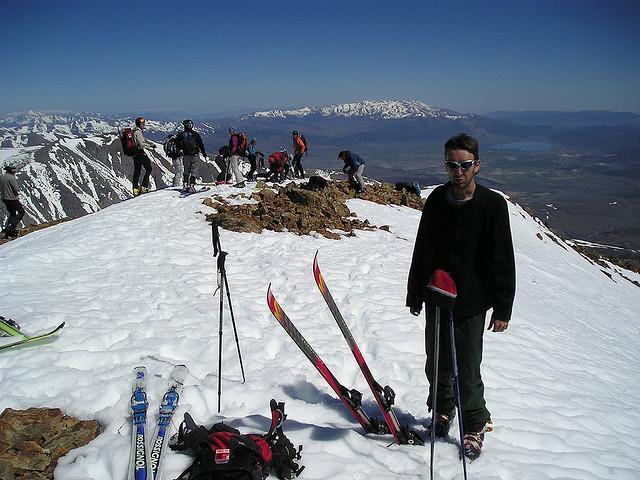How will everyone get off the top of the mountain?
Pick the correct solution from the four options below to address the question.
Options: Belay, jet ski, ropes, ski. Ski. 